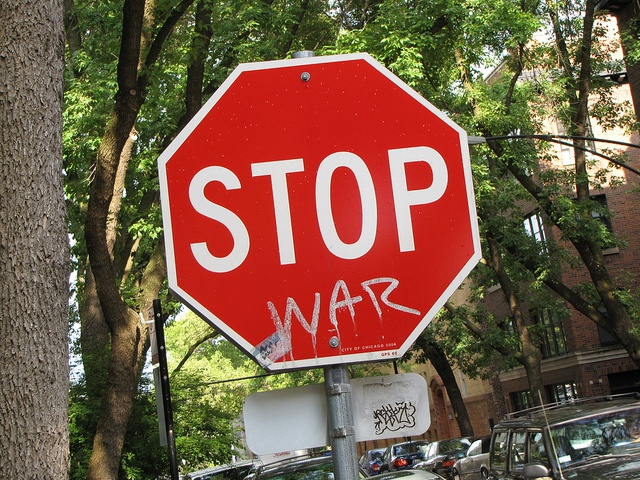Describe the objects in this image and their specific colors. I can see stop sign in black, brown, lightgray, and darkgray tones, car in black, gray, darkgreen, and darkgray tones, car in black, gray, darkgreen, and darkgray tones, car in black, gray, white, and darkgreen tones, and car in black, gray, and darkgray tones in this image. 